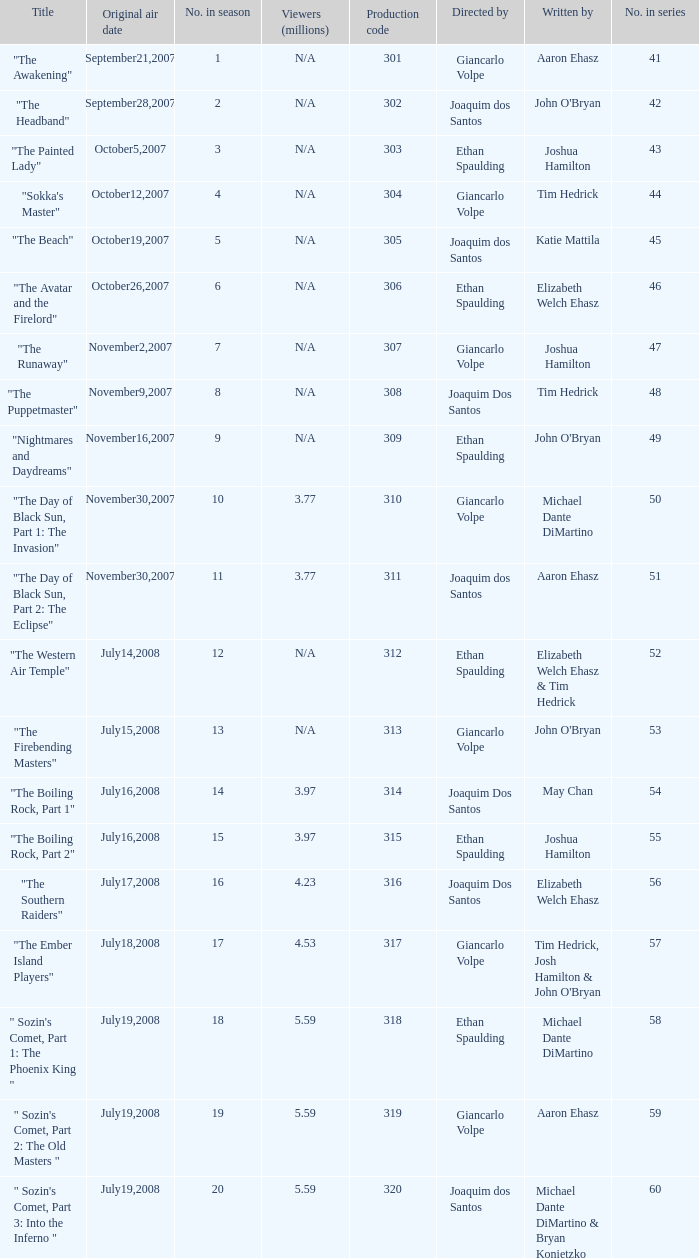How many viewers in millions for episode "sokka's master"? N/A. 